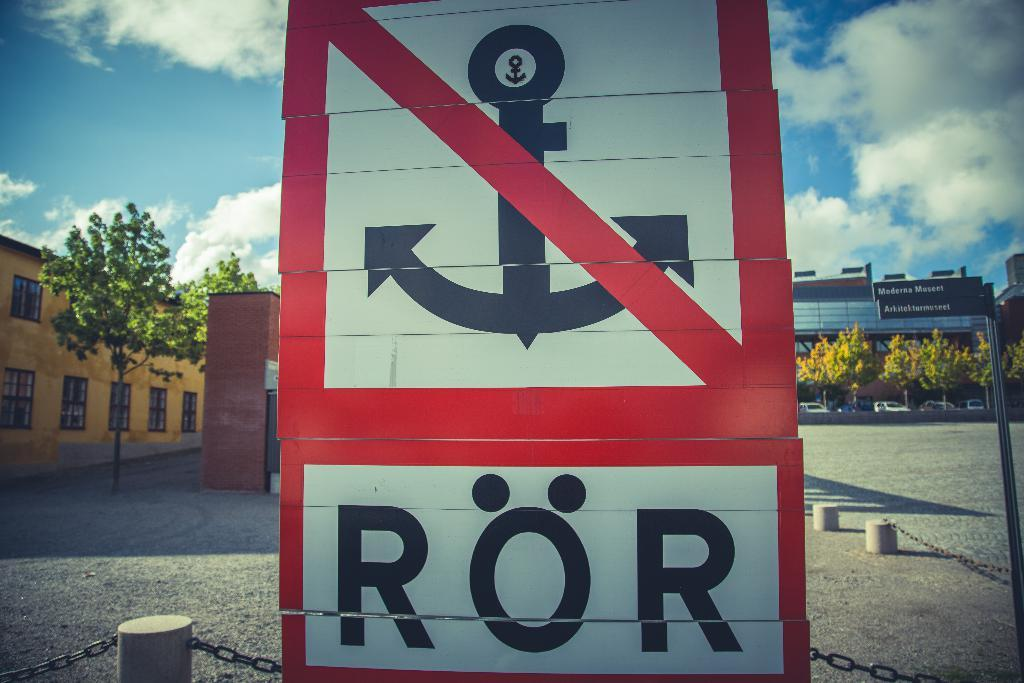<image>
Describe the image concisely. A close up of a sign with a red border, a picture of an anchor with a red line through it and the letters ROR beneath it. 